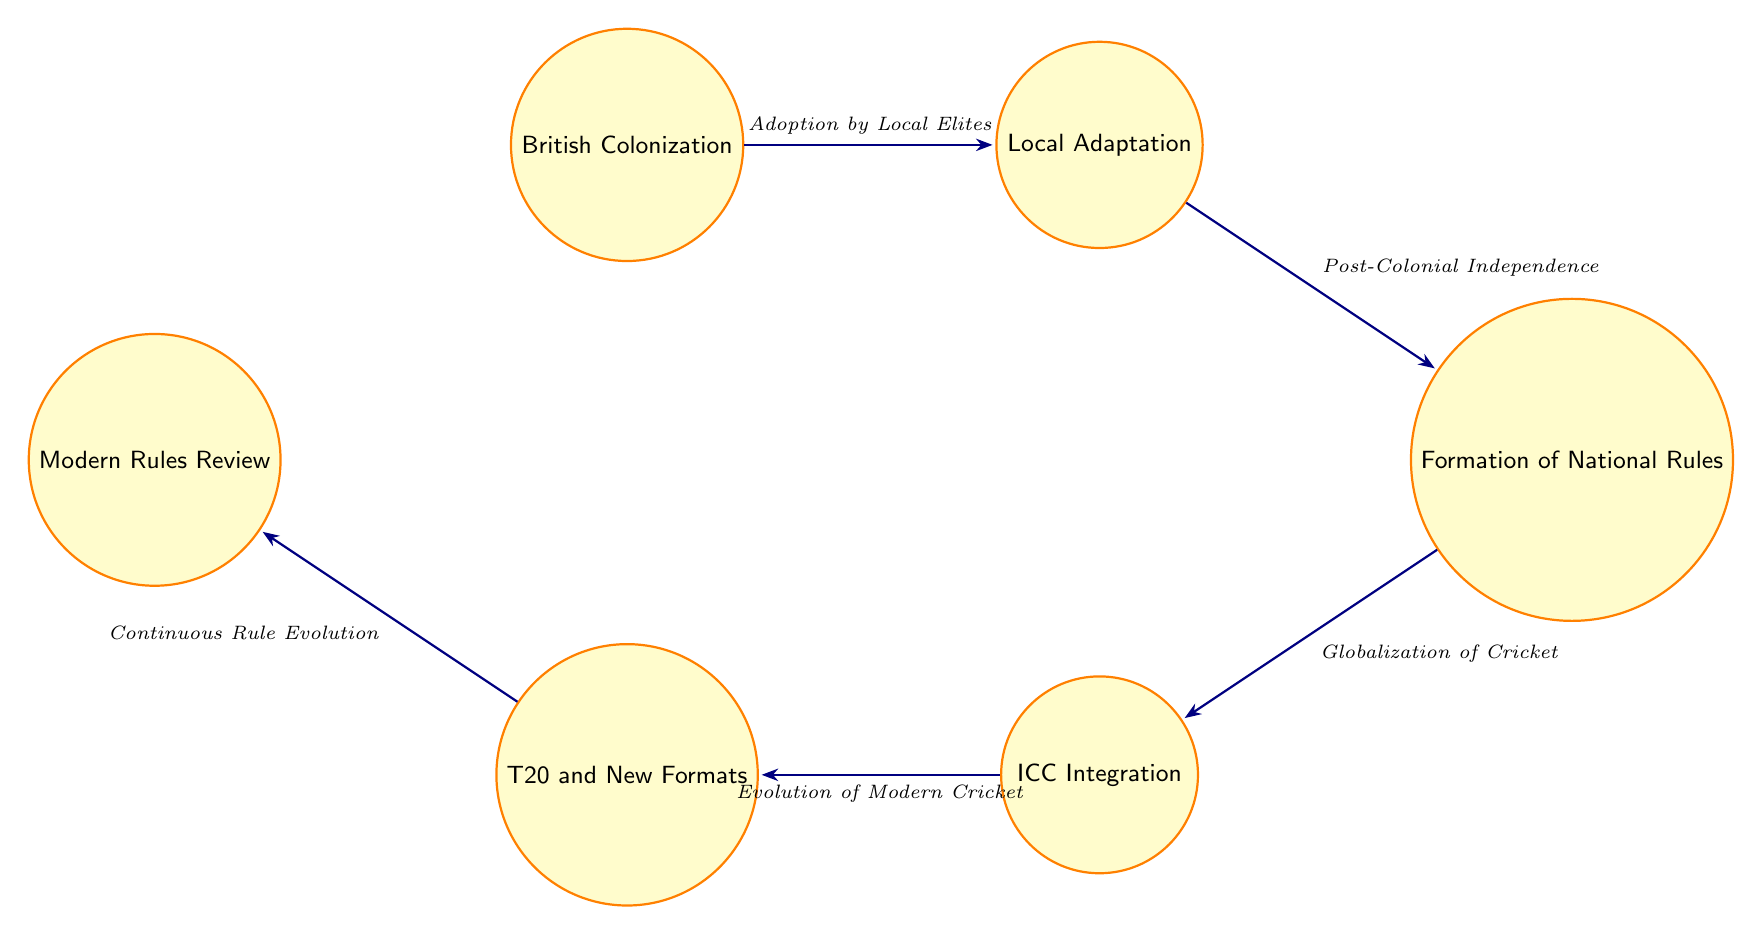What is the first state in the diagram? The first state listed in the diagram is 'British Colonization', which represents the introduction of cricket to colonies.
Answer: British Colonization How many states are in the diagram? The diagram contains a total of six states: British Colonization, Local Adaptation, Formation of National Rules, ICC Integration, T20 and New Formats, and Modern Rules Review.
Answer: 6 What event transitions from 'Local Adaptation'? The event that transitions from 'Local Adaptation' is 'Post-Colonial Independence', indicating a shift in control to local governance.
Answer: Post-Colonial Independence Which state follows 'Formation of National Rules'? The state that follows 'Formation of National Rules' is 'ICC Integration', highlighting the integration of cricket rules at an international level.
Answer: ICC Integration What is the last state in the diagram? The last state in the diagram is 'Modern Rules Review', which signifies ongoing adaptations of cricket rules for contemporary challenges.
Answer: Modern Rules Review How many transitions are from the state 'T20 and New Formats'? The state 'T20 and New Formats' has one transition leading to the state 'Modern Rules Review', showing a continuous evolution of cricket rules.
Answer: 1 Which event leads to 'International Cricket Council Integration'? The event that leads to 'International Cricket Council Integration' is 'Globalization of Cricket', indicating how cricket became standardized globally.
Answer: Globalization of Cricket What is the relationship between 'British Colonization' and 'Local Adaptation'? The relationship is that 'British Colonization' transitions to 'Local Adaptation' when local elites adopt cricket, indicating a change in its practice and rules.
Answer: Adoption by Local Elites What state occurs right before 'T20 and New Formats'? The state that occurs right before 'T20 and New Formats' is 'International Cricket Council Integration', indicating the integration of rules before modern formats emerged.
Answer: ICC Integration 